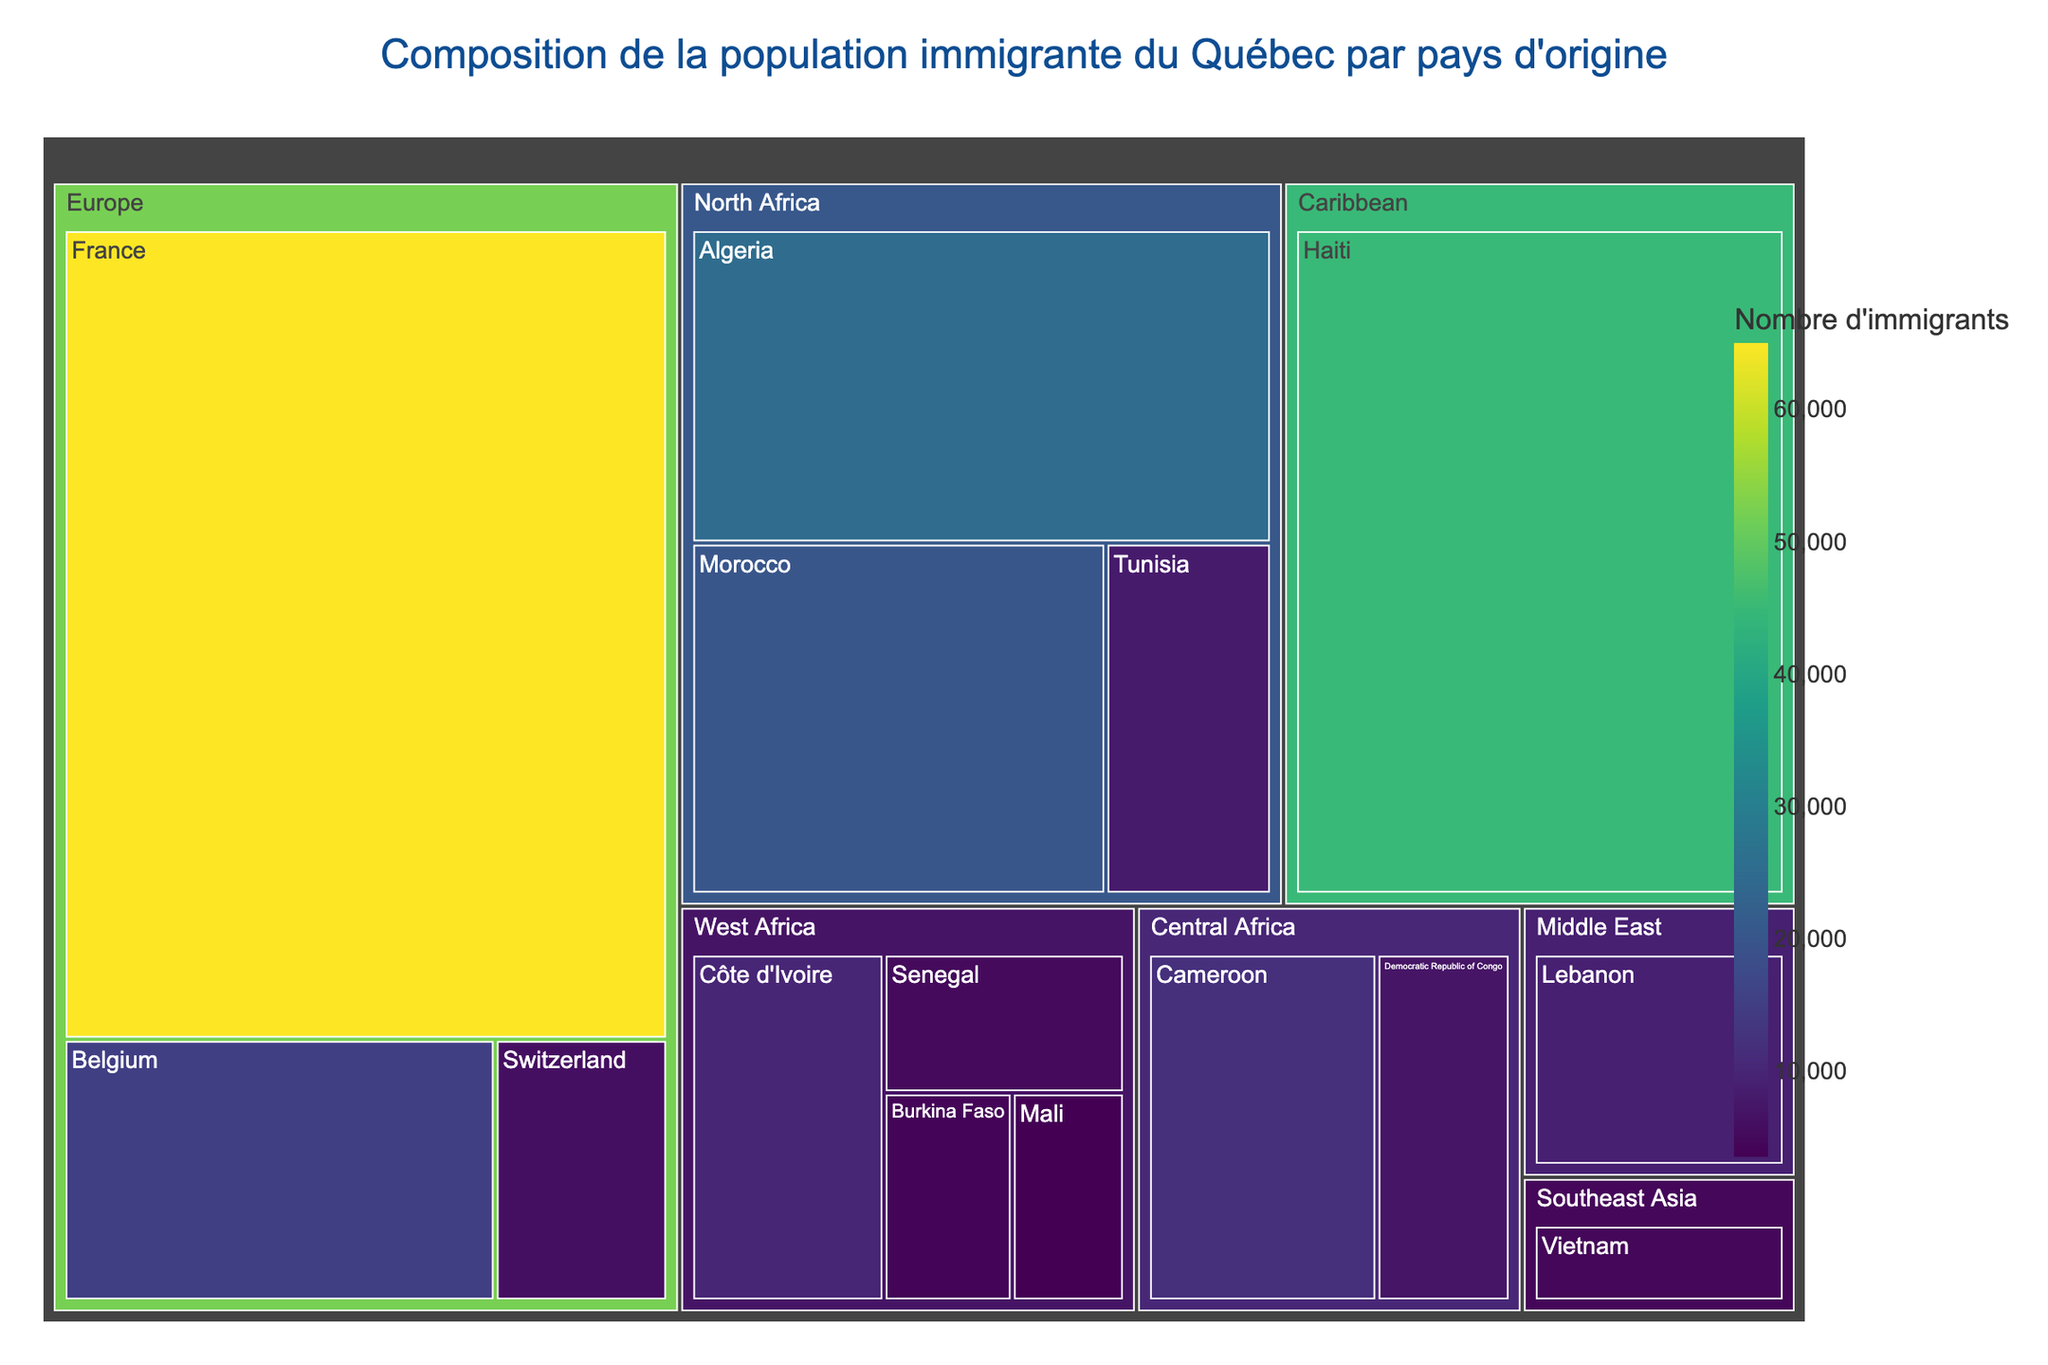Quelle est la région avec le plus grand nombre d'immigrants ? Pour déterminer cela, nous devons examiner la région avec la plus grande taille dans le treemap. La couleur et la taille des rectangles indiquent le nombre d'immigrants. La région 'Europe' est la plus grande.
Answer: Europe Combien d'immigrants viennent d'Afrique de l'Ouest ? Il faut additionner le nombre d'immigrants de la Côte d'Ivoire, du Sénégal, du Burkina Faso, et du Mali. 10,000 + 5,000 + 4,000 + 3,500 = 22,500
Answer: 22,500 Quel est le pays d'origine francophone avec le plus petit nombre d'immigrants ? Examining the smallest rectangles that are labeled with French-speaking countries, 'Mali' has the smallest size indicating it has the fewest immigrants among the labeled French-speaking countries.
Answer: Mali Quel pays européen envoie plus d'immigrants ? Parmi les pays européens, 'France' et 'Belgium' sont mentionnés. Visuellement, le rectangle de 'France' est plus grand.
Answer: France Combien d'immigrants viennent de la région du Moyen-Orient ? Il n'y a qu'un seul pays mentionné dans cette région, 'Lebanon', avec 9,000 immigrants.
Answer: 9,000 Quelle est la différence entre le nombre d'immigrants venant de la France et ceux venant de la Belgique ? Le nombre d'immigrants de la France est 65,000 et de la Belgique est 15,000. La différence est 65,000 - 15,000 = 50,000
Answer: 50,000 Quel continent a le plus grand nombre d'immigrants après l'Europe ? En observant les tailles des rectangles, 'North Africa' vient juste après l'Europe en termes de taille.
Answer: North Africa Combien de pays africains sont représentés dans le treemap ? Les pays africains mentionnés sont : Algeria, Morocco, Cameroon, Côte d'Ivoire, Tunisia, Democratic Republic of Congo, Senegal, Burkina Faso, et Mali. En comptant cela fait 9.
Answer: 9 Quel pays a plus d'immigrants, le Vietnam ou le Liban ? En comparant les tailles des rectangles pour 'Vietnam' (4500) et 'Lebanon' (9000), 'Lebanon' est plus grand.
Answer: Liban Combien d'immigrants viennent des Caraïbes ? Haiti est le seul pays mentionné pour cette région avec 45,000 immigrants.
Answer: 45,000 